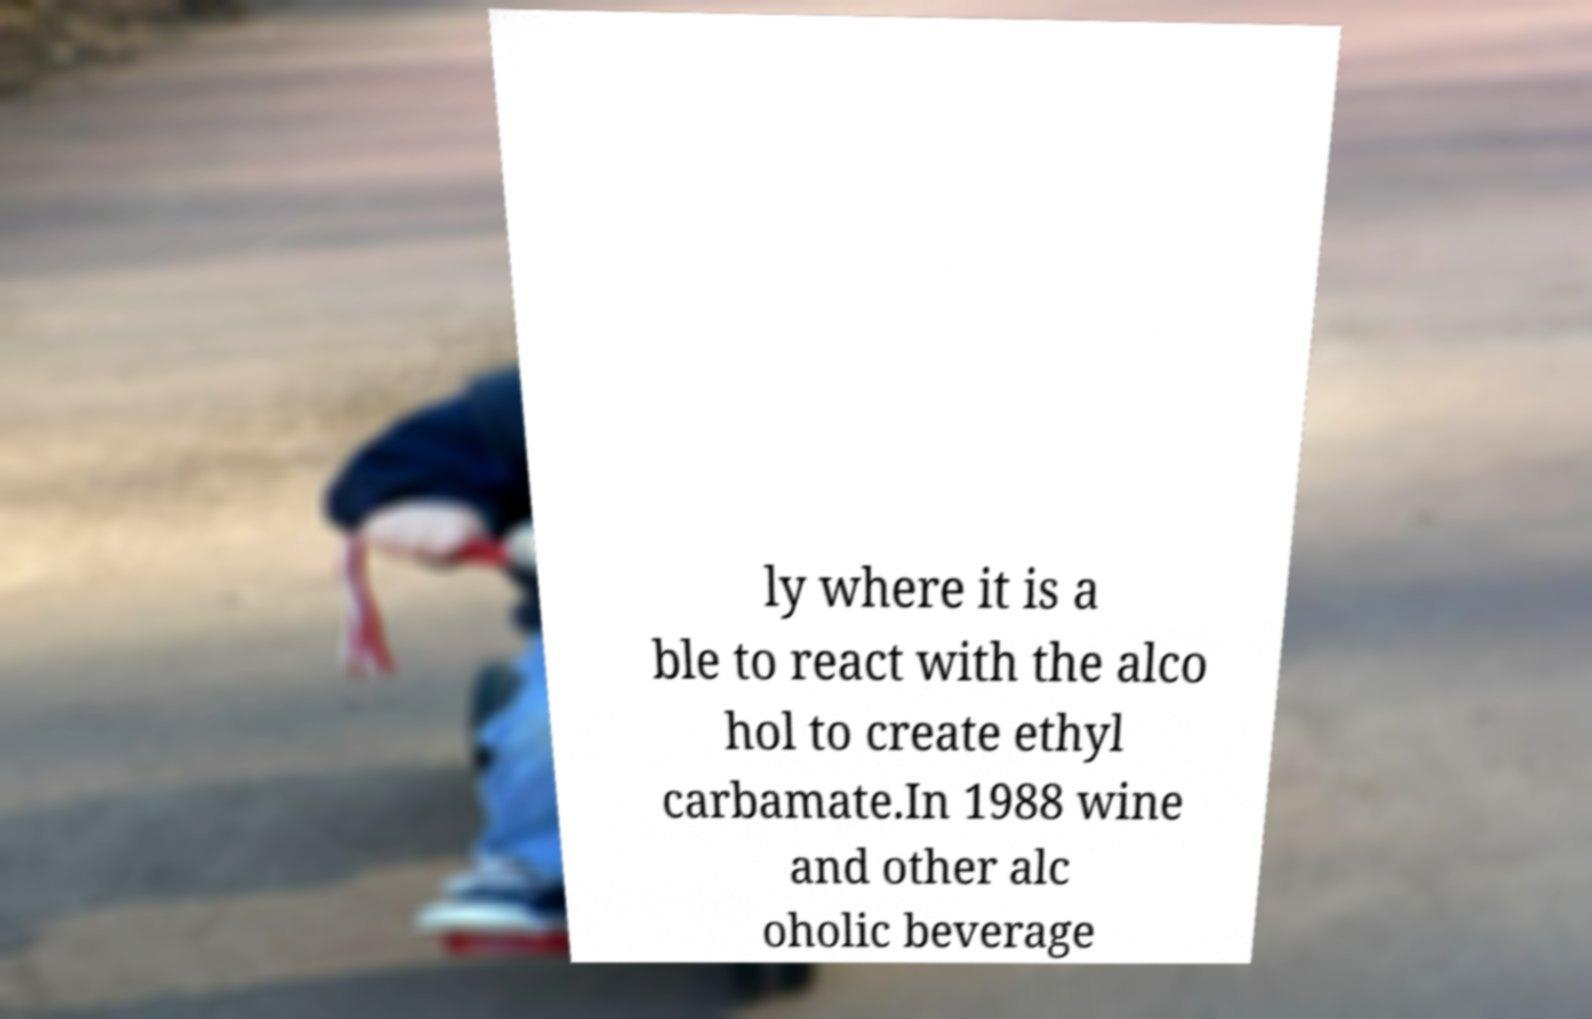Could you extract and type out the text from this image? ly where it is a ble to react with the alco hol to create ethyl carbamate.In 1988 wine and other alc oholic beverage 